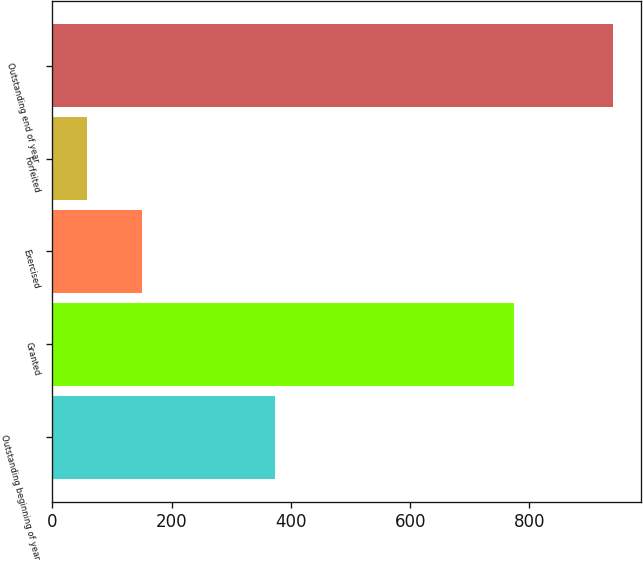<chart> <loc_0><loc_0><loc_500><loc_500><bar_chart><fcel>Outstanding beginning of year<fcel>Granted<fcel>Exercised<fcel>Forfeited<fcel>Outstanding end of year<nl><fcel>374<fcel>774<fcel>150<fcel>58<fcel>940<nl></chart> 